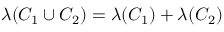Convert formula to latex. <formula><loc_0><loc_0><loc_500><loc_500>\lambda ( C _ { 1 } \cup C _ { 2 } ) = \lambda ( C _ { 1 } ) + \lambda ( C _ { 2 } )</formula> 